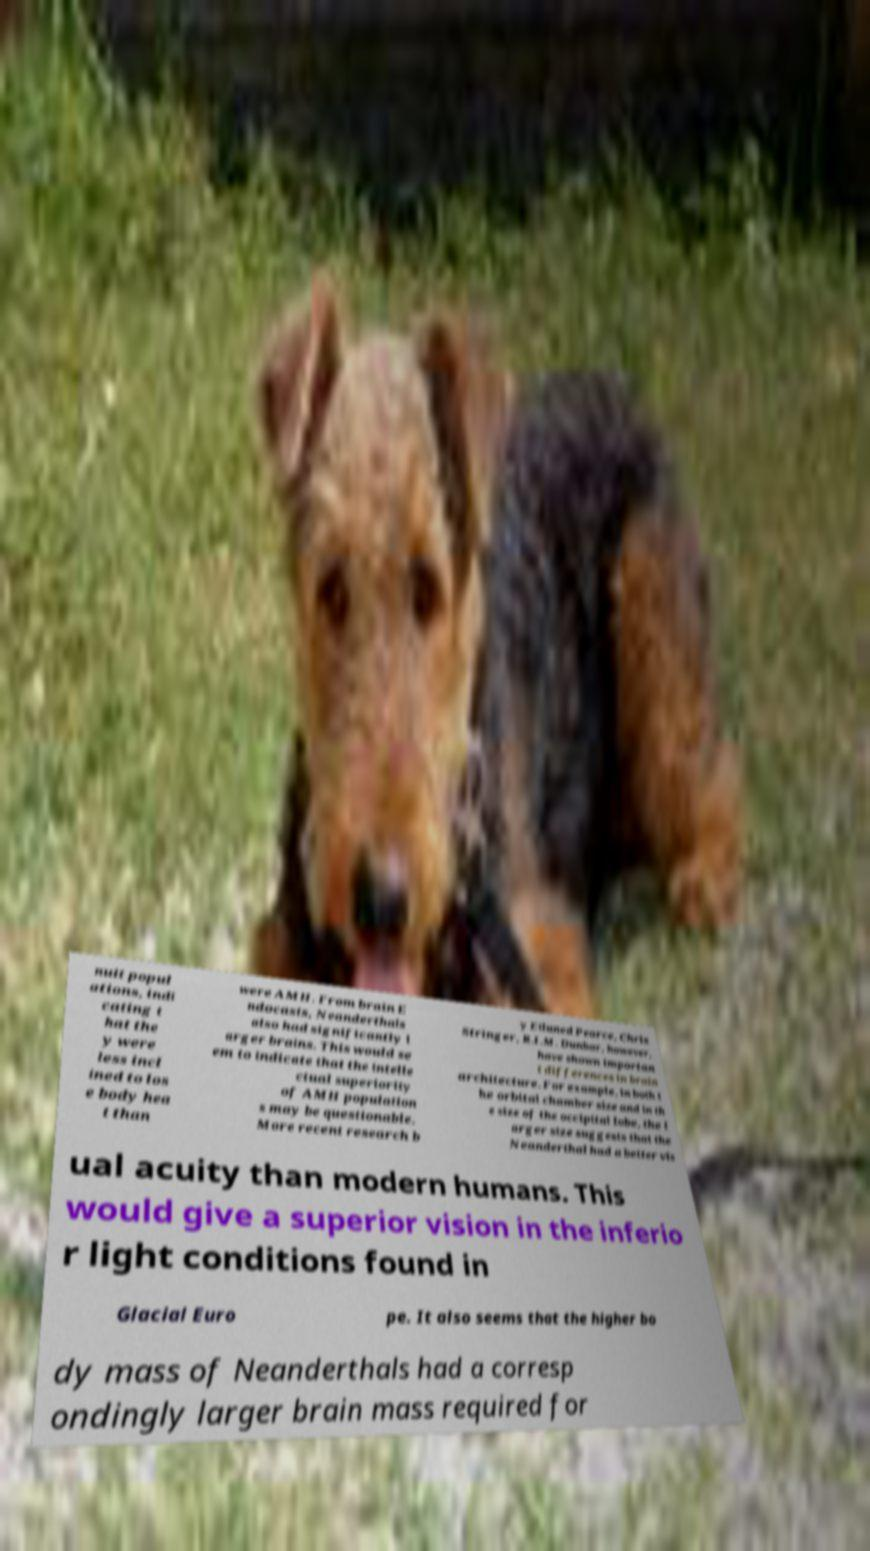Could you assist in decoding the text presented in this image and type it out clearly? nuit popul ations, indi cating t hat the y were less incl ined to los e body hea t than were AMH. From brain E ndocasts, Neanderthals also had significantly l arger brains. This would se em to indicate that the intelle ctual superiority of AMH population s may be questionable. More recent research b y Eiluned Pearce, Chris Stringer, R.I.M. Dunbar, however, have shown importan t differences in brain architecture. For example, in both t he orbital chamber size and in th e size of the occipital lobe, the l arger size suggests that the Neanderthal had a better vis ual acuity than modern humans. This would give a superior vision in the inferio r light conditions found in Glacial Euro pe. It also seems that the higher bo dy mass of Neanderthals had a corresp ondingly larger brain mass required for 